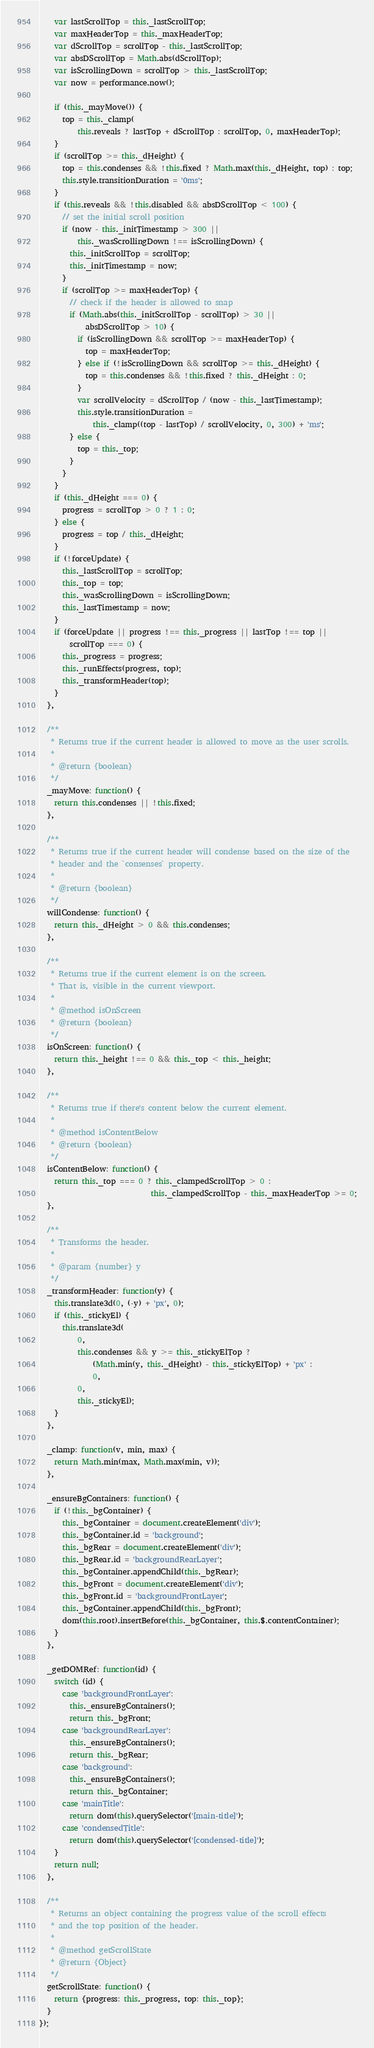Convert code to text. <code><loc_0><loc_0><loc_500><loc_500><_JavaScript_>    var lastScrollTop = this._lastScrollTop;
    var maxHeaderTop = this._maxHeaderTop;
    var dScrollTop = scrollTop - this._lastScrollTop;
    var absDScrollTop = Math.abs(dScrollTop);
    var isScrollingDown = scrollTop > this._lastScrollTop;
    var now = performance.now();

    if (this._mayMove()) {
      top = this._clamp(
          this.reveals ? lastTop + dScrollTop : scrollTop, 0, maxHeaderTop);
    }
    if (scrollTop >= this._dHeight) {
      top = this.condenses && !this.fixed ? Math.max(this._dHeight, top) : top;
      this.style.transitionDuration = '0ms';
    }
    if (this.reveals && !this.disabled && absDScrollTop < 100) {
      // set the initial scroll position
      if (now - this._initTimestamp > 300 ||
          this._wasScrollingDown !== isScrollingDown) {
        this._initScrollTop = scrollTop;
        this._initTimestamp = now;
      }
      if (scrollTop >= maxHeaderTop) {
        // check if the header is allowed to snap
        if (Math.abs(this._initScrollTop - scrollTop) > 30 ||
            absDScrollTop > 10) {
          if (isScrollingDown && scrollTop >= maxHeaderTop) {
            top = maxHeaderTop;
          } else if (!isScrollingDown && scrollTop >= this._dHeight) {
            top = this.condenses && !this.fixed ? this._dHeight : 0;
          }
          var scrollVelocity = dScrollTop / (now - this._lastTimestamp);
          this.style.transitionDuration =
              this._clamp((top - lastTop) / scrollVelocity, 0, 300) + 'ms';
        } else {
          top = this._top;
        }
      }
    }
    if (this._dHeight === 0) {
      progress = scrollTop > 0 ? 1 : 0;
    } else {
      progress = top / this._dHeight;
    }
    if (!forceUpdate) {
      this._lastScrollTop = scrollTop;
      this._top = top;
      this._wasScrollingDown = isScrollingDown;
      this._lastTimestamp = now;
    }
    if (forceUpdate || progress !== this._progress || lastTop !== top ||
        scrollTop === 0) {
      this._progress = progress;
      this._runEffects(progress, top);
      this._transformHeader(top);
    }
  },

  /**
   * Returns true if the current header is allowed to move as the user scrolls.
   *
   * @return {boolean}
   */
  _mayMove: function() {
    return this.condenses || !this.fixed;
  },

  /**
   * Returns true if the current header will condense based on the size of the
   * header and the `consenses` property.
   *
   * @return {boolean}
   */
  willCondense: function() {
    return this._dHeight > 0 && this.condenses;
  },

  /**
   * Returns true if the current element is on the screen.
   * That is, visible in the current viewport.
   *
   * @method isOnScreen
   * @return {boolean}
   */
  isOnScreen: function() {
    return this._height !== 0 && this._top < this._height;
  },

  /**
   * Returns true if there's content below the current element.
   *
   * @method isContentBelow
   * @return {boolean}
   */
  isContentBelow: function() {
    return this._top === 0 ? this._clampedScrollTop > 0 :
                             this._clampedScrollTop - this._maxHeaderTop >= 0;
  },

  /**
   * Transforms the header.
   *
   * @param {number} y
   */
  _transformHeader: function(y) {
    this.translate3d(0, (-y) + 'px', 0);
    if (this._stickyEl) {
      this.translate3d(
          0,
          this.condenses && y >= this._stickyElTop ?
              (Math.min(y, this._dHeight) - this._stickyElTop) + 'px' :
              0,
          0,
          this._stickyEl);
    }
  },

  _clamp: function(v, min, max) {
    return Math.min(max, Math.max(min, v));
  },

  _ensureBgContainers: function() {
    if (!this._bgContainer) {
      this._bgContainer = document.createElement('div');
      this._bgContainer.id = 'background';
      this._bgRear = document.createElement('div');
      this._bgRear.id = 'backgroundRearLayer';
      this._bgContainer.appendChild(this._bgRear);
      this._bgFront = document.createElement('div');
      this._bgFront.id = 'backgroundFrontLayer';
      this._bgContainer.appendChild(this._bgFront);
      dom(this.root).insertBefore(this._bgContainer, this.$.contentContainer);
    }
  },

  _getDOMRef: function(id) {
    switch (id) {
      case 'backgroundFrontLayer':
        this._ensureBgContainers();
        return this._bgFront;
      case 'backgroundRearLayer':
        this._ensureBgContainers();
        return this._bgRear;
      case 'background':
        this._ensureBgContainers();
        return this._bgContainer;
      case 'mainTitle':
        return dom(this).querySelector('[main-title]');
      case 'condensedTitle':
        return dom(this).querySelector('[condensed-title]');
    }
    return null;
  },

  /**
   * Returns an object containing the progress value of the scroll effects
   * and the top position of the header.
   *
   * @method getScrollState
   * @return {Object}
   */
  getScrollState: function() {
    return {progress: this._progress, top: this._top};
  }
});
</code> 